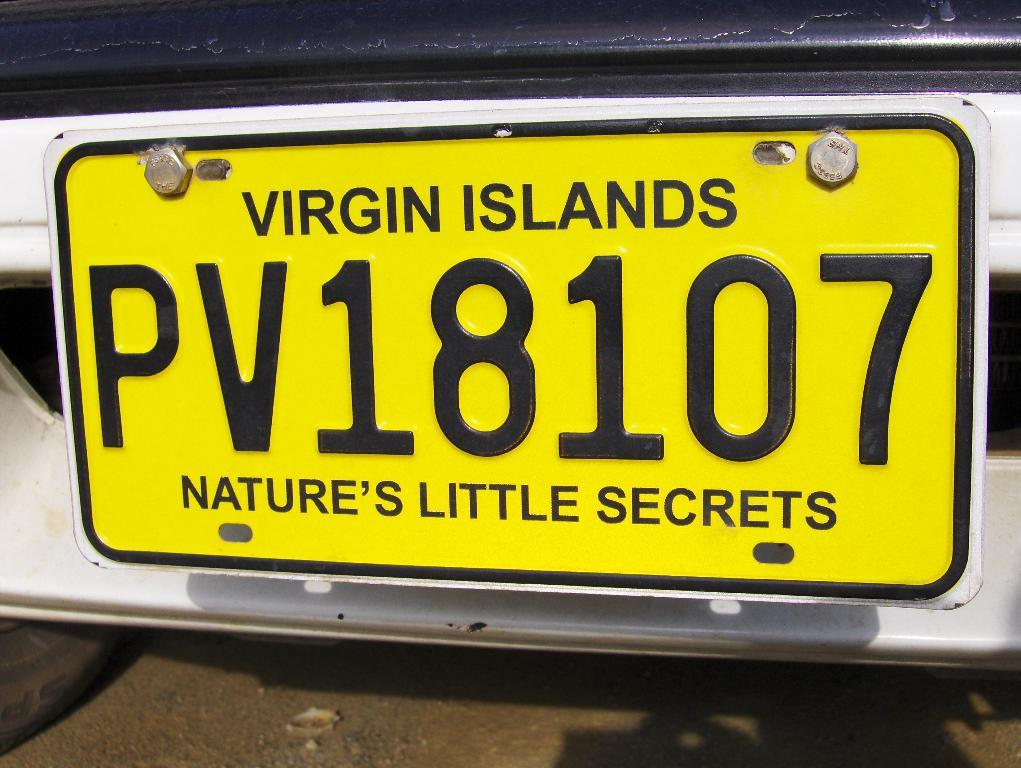<image>
Give a short and clear explanation of the subsequent image. A yellow Virgin Islands license plate with PV18107 on it. 